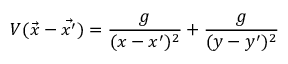<formula> <loc_0><loc_0><loc_500><loc_500>V ( \vec { x } - \vec { x ^ { \prime } } ) = \frac { g } { ( x - x ^ { \prime } ) ^ { 2 } } + \frac { g } { ( y - y ^ { \prime } ) ^ { 2 } }</formula> 